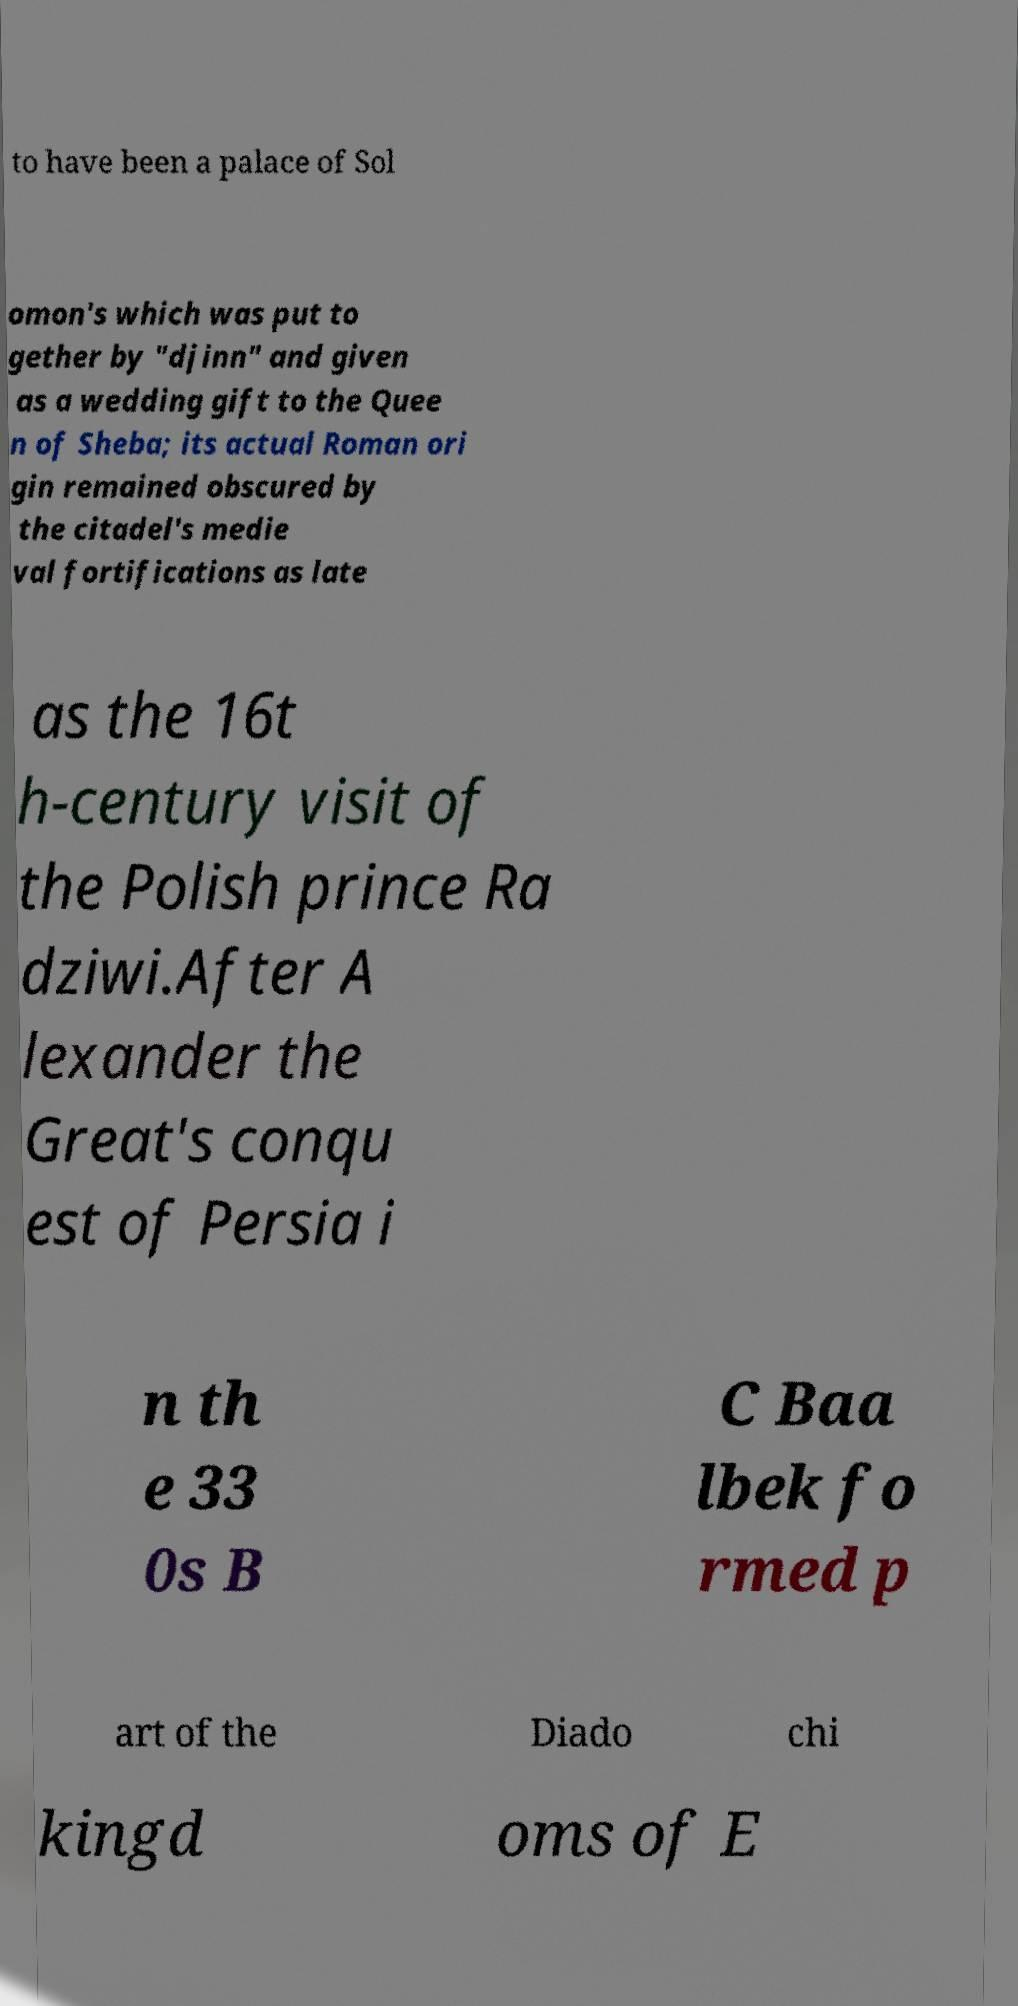There's text embedded in this image that I need extracted. Can you transcribe it verbatim? to have been a palace of Sol omon's which was put to gether by "djinn" and given as a wedding gift to the Quee n of Sheba; its actual Roman ori gin remained obscured by the citadel's medie val fortifications as late as the 16t h-century visit of the Polish prince Ra dziwi.After A lexander the Great's conqu est of Persia i n th e 33 0s B C Baa lbek fo rmed p art of the Diado chi kingd oms of E 